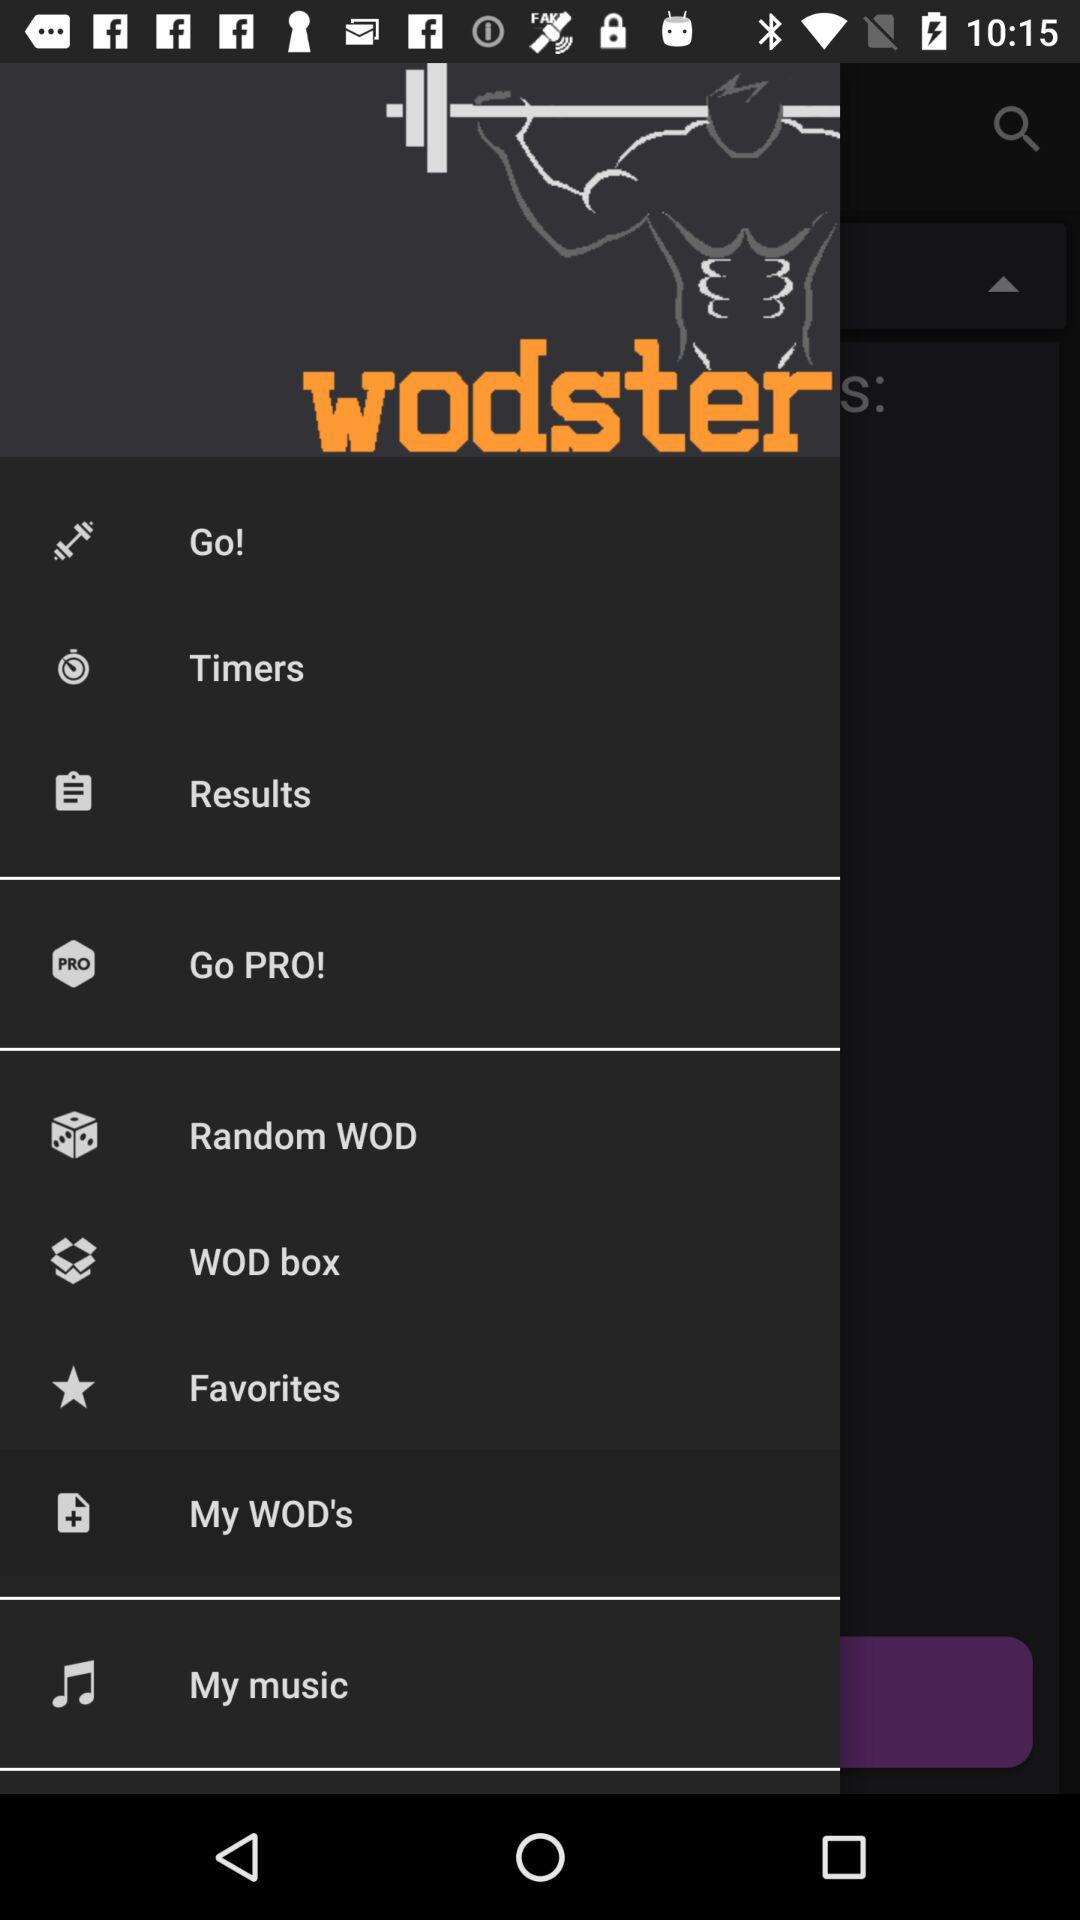What is the name of the application? The name of the application is "wodster". 